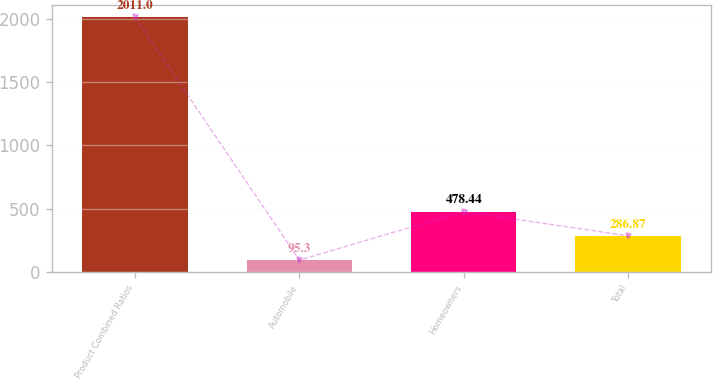Convert chart to OTSL. <chart><loc_0><loc_0><loc_500><loc_500><bar_chart><fcel>Product Combined Ratios<fcel>Automobile<fcel>Homeowners<fcel>Total<nl><fcel>2011<fcel>95.3<fcel>478.44<fcel>286.87<nl></chart> 